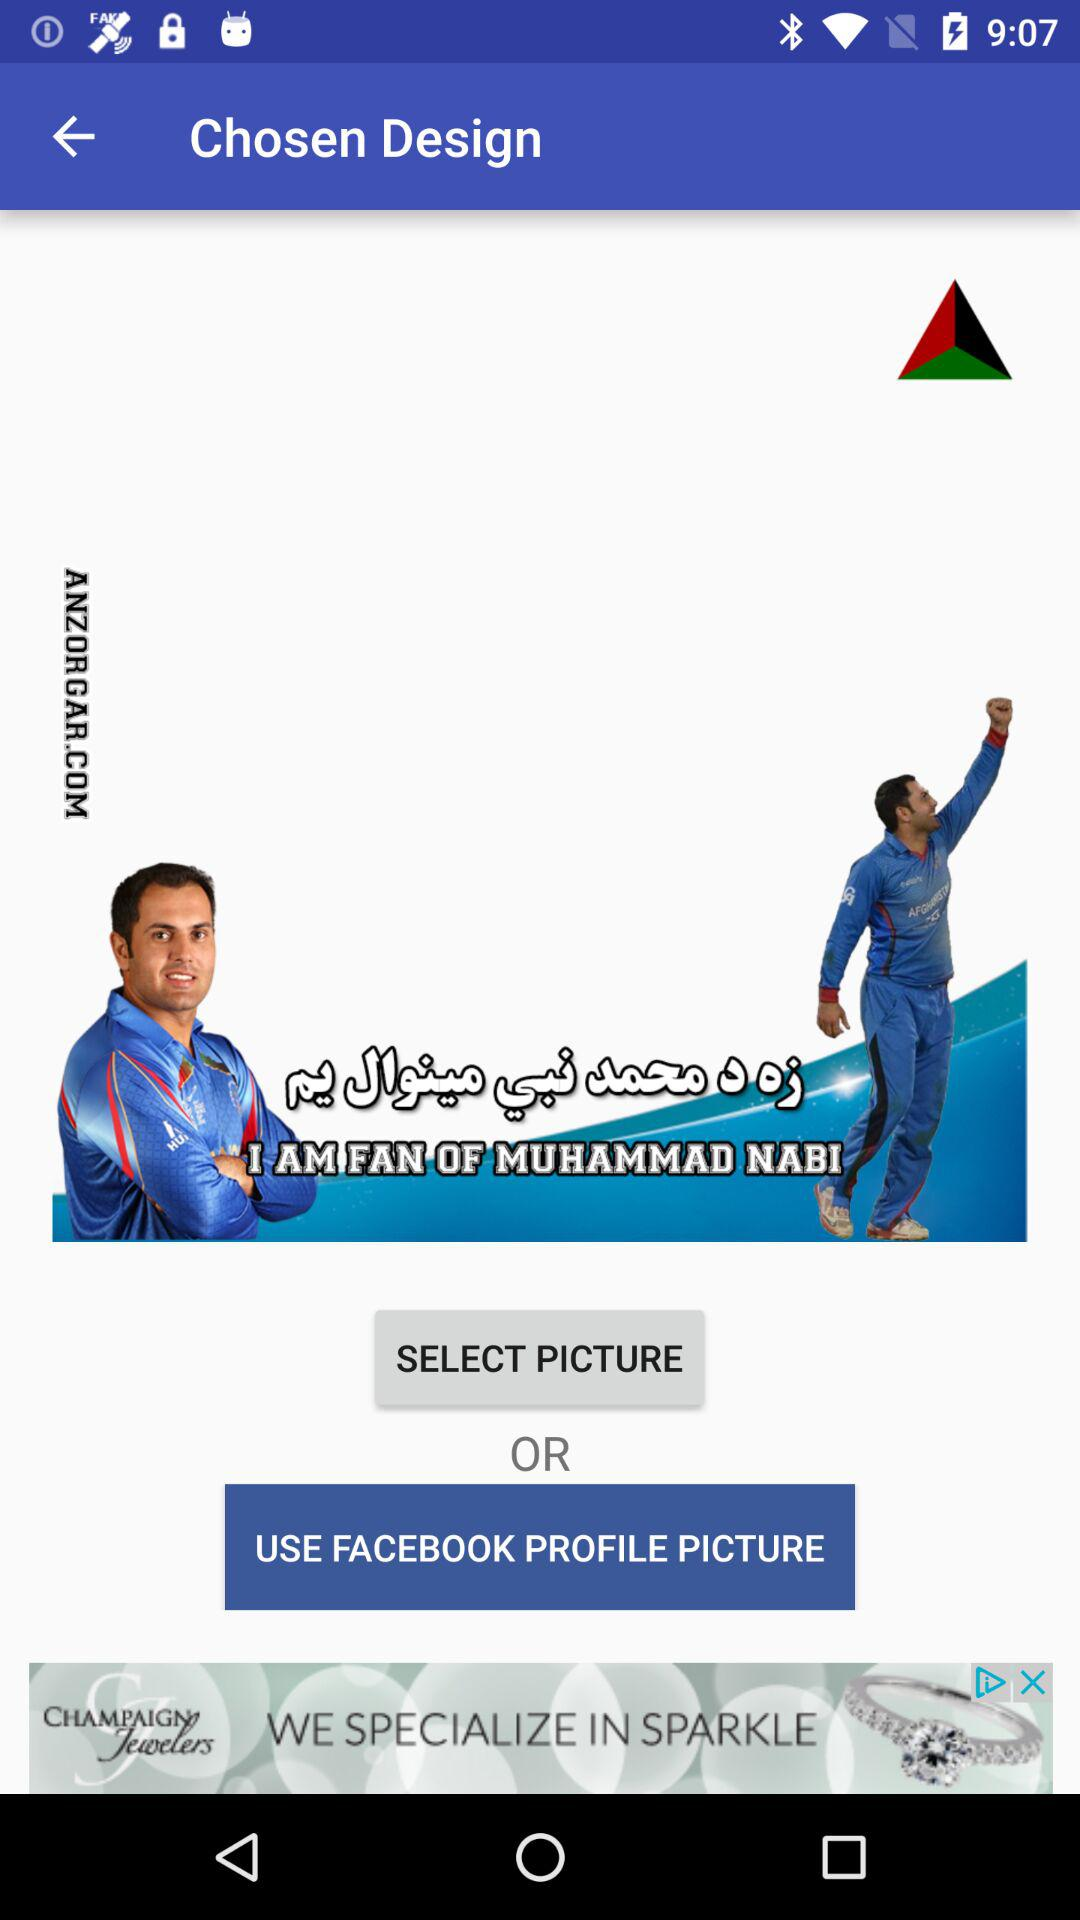What other application can I use to change the profile picture? The application is "FACEBOOK". 